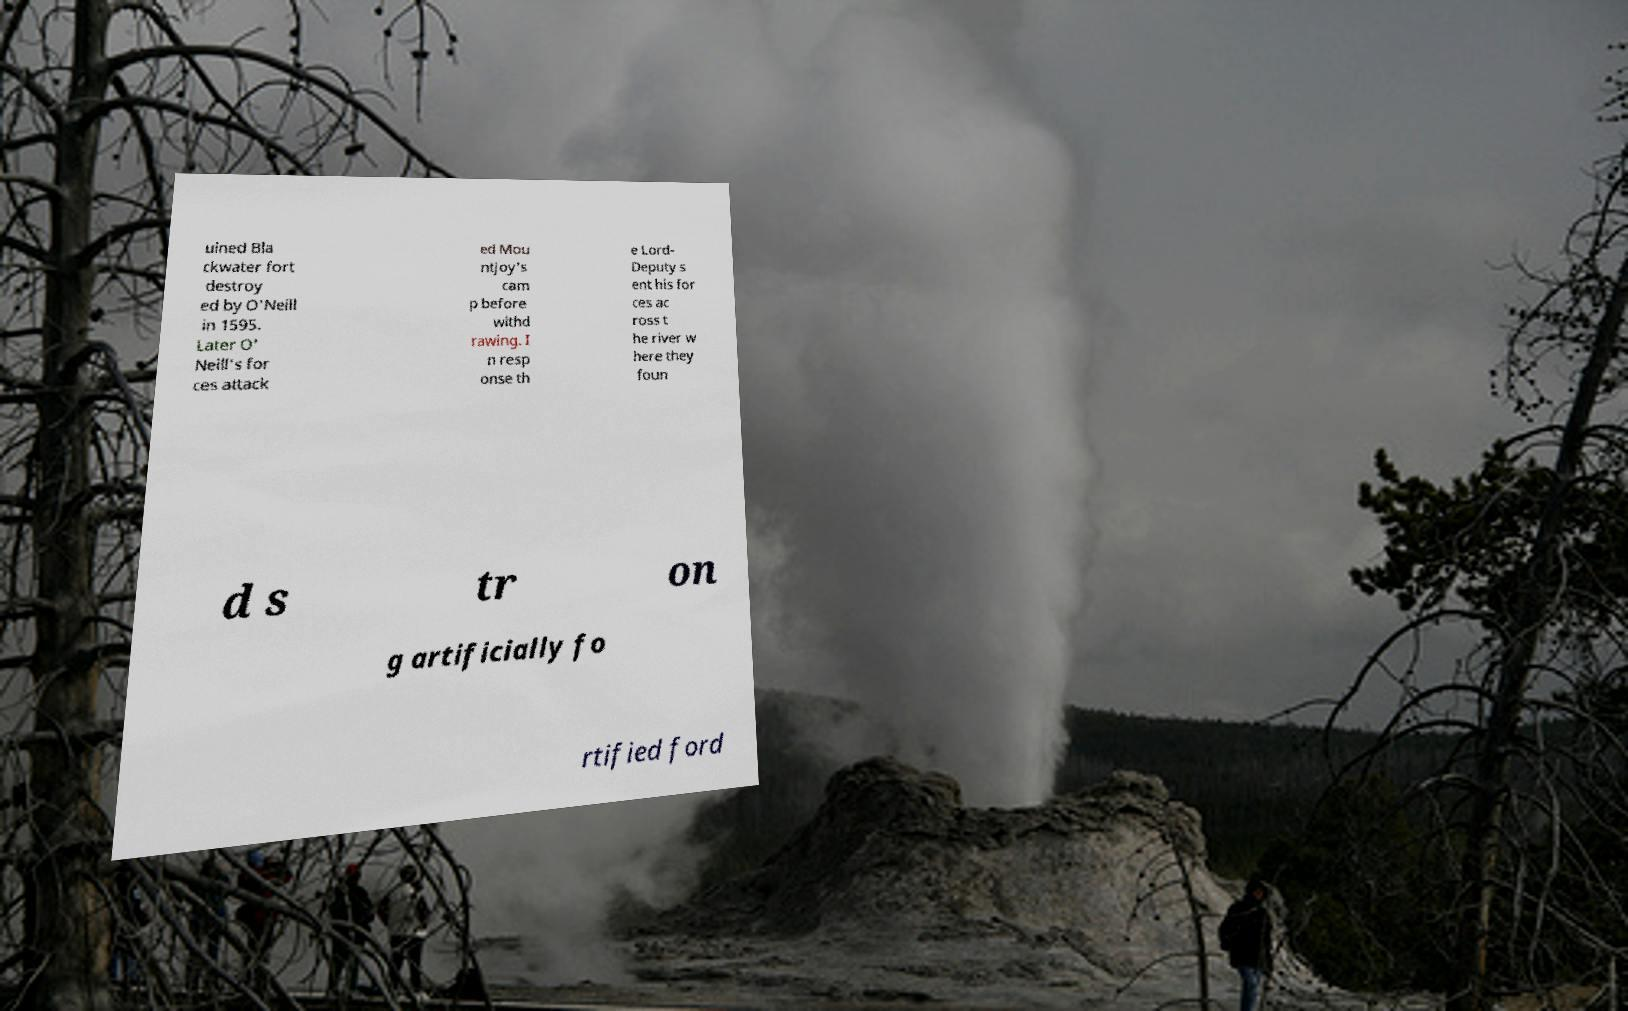There's text embedded in this image that I need extracted. Can you transcribe it verbatim? uined Bla ckwater fort destroy ed by O'Neill in 1595. Later O' Neill's for ces attack ed Mou ntjoy's cam p before withd rawing. I n resp onse th e Lord- Deputy s ent his for ces ac ross t he river w here they foun d s tr on g artificially fo rtified ford 